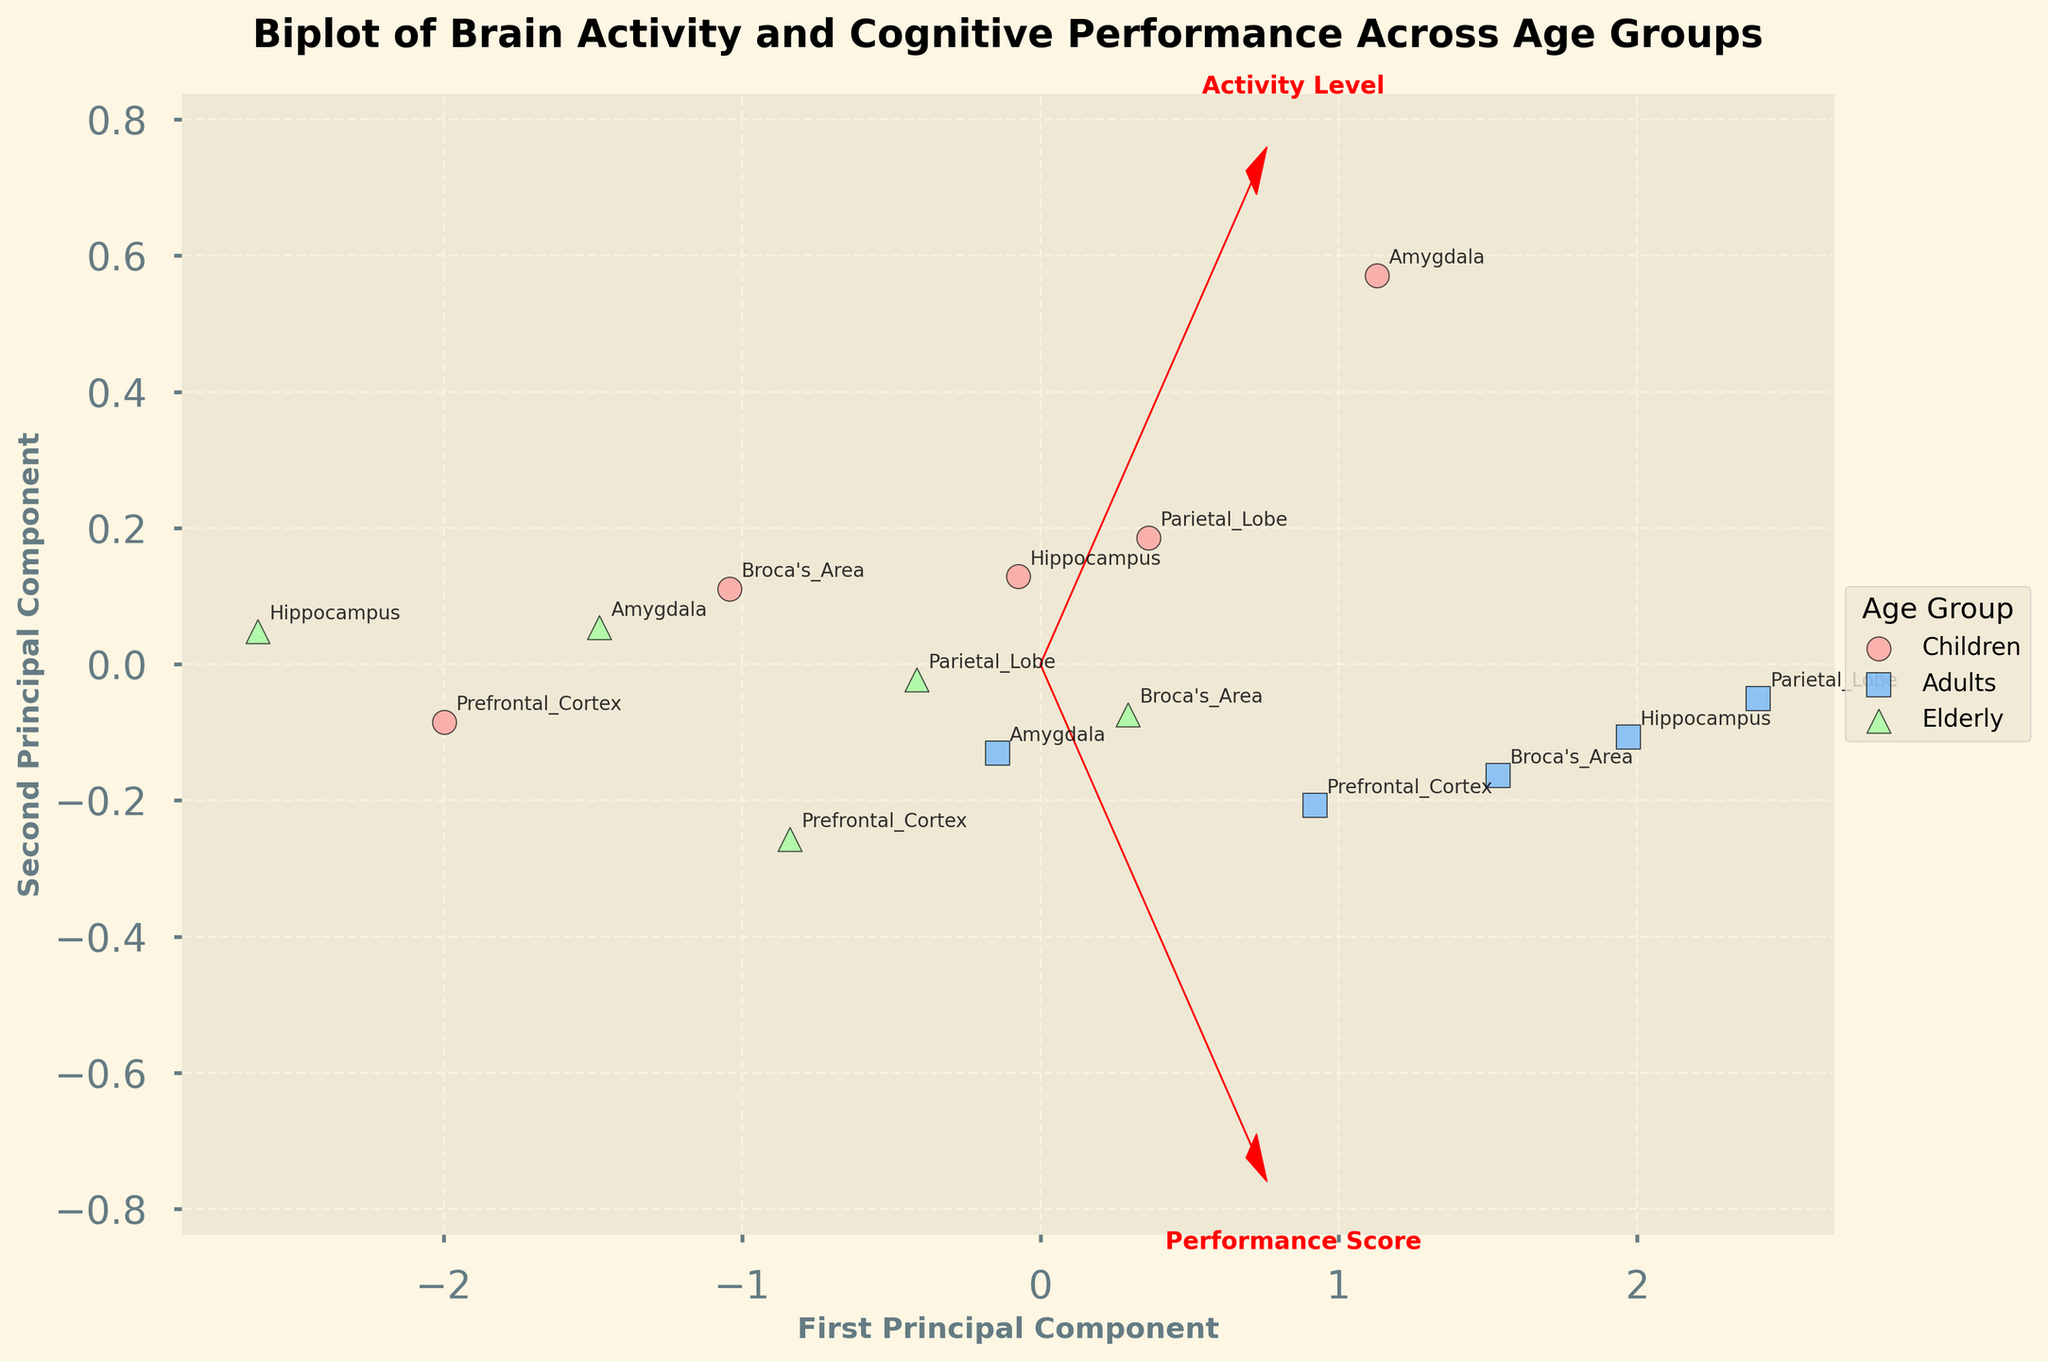How many data points are represented in the figure? To determine the number of data points, find the number of different markers plotted in the figure. Since each row in the provided data corresponds to a point, count the rows, resulting in 15 data points.
Answer: 15 What colors are used to represent the different age groups? The plot shows three distinct colors for each age group. Determine the specific colors by looking at the legend.
Answer: Children: Light Red, Adults: Light Blue, Elderly: Light Green Which age group shows the highest variance in Activity Level and Performance Score? Based on the spread of data points along the principal components, the variance can be visually estimated by seeing the scatter distribution. The age group with points spread farthest from the center has the highest variance.
Answer: Adults Which age group has the highest concentration of data points near the origin? Identify the age group whose points are closest to (0,0) in the PCA plot. The origin represents mean values after scaling, so the densest group should be noted.
Answer: Elderly How does the 'Activity Level' feature vector align in terms of principal components? Look at the red arrows representing the 'Activity Level' in the plot. Analyze its direction and the signs along the PCA axes.
Answer: Mainly along the First Principal Component Compare the Performance Score between Children and Elderly based on the plot. Which group performs better on average? Check the positions of the data points for both Children and Elderly age groups. The group with points situated farther right along the Performance Score vector is better-performing on average.
Answer: Children How does the Prefrontal Cortex's activity correlate with Executive Function across age groups visually? Find the annotations corresponding to the Prefrontal Cortex and Executive Function. Examine the data points and their spread regarding executive function scores and related features.
Answer: Strong positive correlation Determine the region with the most consistent activity levels across all age groups. Compare the annotations of different brain regions and assess their points' spread. The region with the least variation across age groups is most consistent.
Answer: Broca's Area Which cognitive function shows the highest positive correlation with its associated activity level? By inspecting the length and direction of feature vectors in the plot, longer arrows aligned positively with PCA components denote higher correlations.
Answer: Memory Formation in Hippocampus How are the elderlies performing in Emotional Processing compared to others based on the plot? Seek out the annotations for Amygdala and study points' positions for Elderly age group relative to other age groups. Consider their performance scores in relation to the corresponding vectors.
Answer: Lower than Children but similar to Adults 